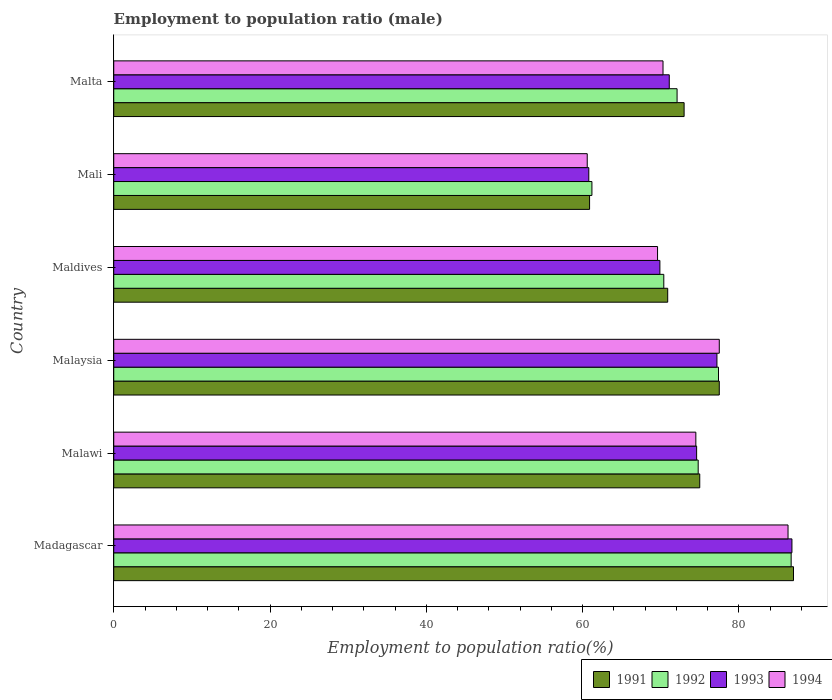How many groups of bars are there?
Make the answer very short. 6. Are the number of bars on each tick of the Y-axis equal?
Give a very brief answer. Yes. How many bars are there on the 5th tick from the top?
Your answer should be compact. 4. What is the label of the 3rd group of bars from the top?
Your answer should be compact. Maldives. In how many cases, is the number of bars for a given country not equal to the number of legend labels?
Keep it short and to the point. 0. What is the employment to population ratio in 1993 in Mali?
Ensure brevity in your answer.  60.8. Across all countries, what is the minimum employment to population ratio in 1992?
Offer a terse response. 61.2. In which country was the employment to population ratio in 1992 maximum?
Give a very brief answer. Madagascar. In which country was the employment to population ratio in 1993 minimum?
Offer a terse response. Mali. What is the total employment to population ratio in 1993 in the graph?
Provide a succinct answer. 440.4. What is the difference between the employment to population ratio in 1994 in Madagascar and that in Malawi?
Keep it short and to the point. 11.8. What is the difference between the employment to population ratio in 1993 in Maldives and the employment to population ratio in 1991 in Malawi?
Your answer should be compact. -5.1. What is the average employment to population ratio in 1992 per country?
Your response must be concise. 73.77. What is the difference between the employment to population ratio in 1994 and employment to population ratio in 1993 in Madagascar?
Your response must be concise. -0.5. What is the ratio of the employment to population ratio in 1992 in Malawi to that in Maldives?
Make the answer very short. 1.06. What is the difference between the highest and the second highest employment to population ratio in 1993?
Offer a terse response. 9.6. What is the difference between the highest and the lowest employment to population ratio in 1991?
Your answer should be compact. 26.1. Is the sum of the employment to population ratio in 1994 in Madagascar and Maldives greater than the maximum employment to population ratio in 1992 across all countries?
Your answer should be very brief. Yes. Is it the case that in every country, the sum of the employment to population ratio in 1992 and employment to population ratio in 1994 is greater than the sum of employment to population ratio in 1993 and employment to population ratio in 1991?
Provide a succinct answer. No. What does the 2nd bar from the top in Mali represents?
Make the answer very short. 1993. Is it the case that in every country, the sum of the employment to population ratio in 1991 and employment to population ratio in 1994 is greater than the employment to population ratio in 1992?
Your answer should be compact. Yes. What is the difference between two consecutive major ticks on the X-axis?
Your answer should be compact. 20. Does the graph contain any zero values?
Your answer should be very brief. No. Does the graph contain grids?
Make the answer very short. No. Where does the legend appear in the graph?
Make the answer very short. Bottom right. How many legend labels are there?
Ensure brevity in your answer.  4. How are the legend labels stacked?
Your answer should be very brief. Horizontal. What is the title of the graph?
Keep it short and to the point. Employment to population ratio (male). Does "2001" appear as one of the legend labels in the graph?
Offer a very short reply. No. What is the Employment to population ratio(%) of 1991 in Madagascar?
Ensure brevity in your answer.  87. What is the Employment to population ratio(%) in 1992 in Madagascar?
Offer a very short reply. 86.7. What is the Employment to population ratio(%) in 1993 in Madagascar?
Offer a terse response. 86.8. What is the Employment to population ratio(%) in 1994 in Madagascar?
Your answer should be very brief. 86.3. What is the Employment to population ratio(%) of 1991 in Malawi?
Your answer should be very brief. 75. What is the Employment to population ratio(%) in 1992 in Malawi?
Offer a very short reply. 74.8. What is the Employment to population ratio(%) in 1993 in Malawi?
Provide a short and direct response. 74.6. What is the Employment to population ratio(%) of 1994 in Malawi?
Keep it short and to the point. 74.5. What is the Employment to population ratio(%) in 1991 in Malaysia?
Provide a short and direct response. 77.5. What is the Employment to population ratio(%) in 1992 in Malaysia?
Provide a short and direct response. 77.4. What is the Employment to population ratio(%) of 1993 in Malaysia?
Your response must be concise. 77.2. What is the Employment to population ratio(%) of 1994 in Malaysia?
Offer a terse response. 77.5. What is the Employment to population ratio(%) of 1991 in Maldives?
Your answer should be compact. 70.9. What is the Employment to population ratio(%) in 1992 in Maldives?
Give a very brief answer. 70.4. What is the Employment to population ratio(%) of 1993 in Maldives?
Offer a terse response. 69.9. What is the Employment to population ratio(%) of 1994 in Maldives?
Your answer should be compact. 69.6. What is the Employment to population ratio(%) in 1991 in Mali?
Offer a very short reply. 60.9. What is the Employment to population ratio(%) in 1992 in Mali?
Your answer should be compact. 61.2. What is the Employment to population ratio(%) in 1993 in Mali?
Provide a succinct answer. 60.8. What is the Employment to population ratio(%) in 1994 in Mali?
Offer a terse response. 60.6. What is the Employment to population ratio(%) in 1992 in Malta?
Provide a short and direct response. 72.1. What is the Employment to population ratio(%) of 1993 in Malta?
Your answer should be very brief. 71.1. What is the Employment to population ratio(%) in 1994 in Malta?
Offer a terse response. 70.3. Across all countries, what is the maximum Employment to population ratio(%) of 1991?
Offer a very short reply. 87. Across all countries, what is the maximum Employment to population ratio(%) in 1992?
Make the answer very short. 86.7. Across all countries, what is the maximum Employment to population ratio(%) of 1993?
Provide a succinct answer. 86.8. Across all countries, what is the maximum Employment to population ratio(%) of 1994?
Give a very brief answer. 86.3. Across all countries, what is the minimum Employment to population ratio(%) of 1991?
Offer a terse response. 60.9. Across all countries, what is the minimum Employment to population ratio(%) in 1992?
Your answer should be compact. 61.2. Across all countries, what is the minimum Employment to population ratio(%) of 1993?
Keep it short and to the point. 60.8. Across all countries, what is the minimum Employment to population ratio(%) in 1994?
Your answer should be very brief. 60.6. What is the total Employment to population ratio(%) in 1991 in the graph?
Provide a short and direct response. 444.3. What is the total Employment to population ratio(%) of 1992 in the graph?
Make the answer very short. 442.6. What is the total Employment to population ratio(%) in 1993 in the graph?
Offer a very short reply. 440.4. What is the total Employment to population ratio(%) of 1994 in the graph?
Keep it short and to the point. 438.8. What is the difference between the Employment to population ratio(%) of 1993 in Madagascar and that in Malawi?
Ensure brevity in your answer.  12.2. What is the difference between the Employment to population ratio(%) in 1991 in Madagascar and that in Malaysia?
Make the answer very short. 9.5. What is the difference between the Employment to population ratio(%) in 1994 in Madagascar and that in Malaysia?
Ensure brevity in your answer.  8.8. What is the difference between the Employment to population ratio(%) in 1991 in Madagascar and that in Maldives?
Offer a terse response. 16.1. What is the difference between the Employment to population ratio(%) of 1992 in Madagascar and that in Maldives?
Offer a very short reply. 16.3. What is the difference between the Employment to population ratio(%) of 1991 in Madagascar and that in Mali?
Provide a short and direct response. 26.1. What is the difference between the Employment to population ratio(%) in 1993 in Madagascar and that in Mali?
Your answer should be compact. 26. What is the difference between the Employment to population ratio(%) of 1994 in Madagascar and that in Mali?
Ensure brevity in your answer.  25.7. What is the difference between the Employment to population ratio(%) in 1991 in Madagascar and that in Malta?
Your answer should be very brief. 14. What is the difference between the Employment to population ratio(%) of 1992 in Madagascar and that in Malta?
Keep it short and to the point. 14.6. What is the difference between the Employment to population ratio(%) of 1993 in Madagascar and that in Malta?
Provide a succinct answer. 15.7. What is the difference between the Employment to population ratio(%) of 1993 in Malawi and that in Malaysia?
Offer a very short reply. -2.6. What is the difference between the Employment to population ratio(%) in 1993 in Malawi and that in Maldives?
Offer a terse response. 4.7. What is the difference between the Employment to population ratio(%) in 1991 in Malawi and that in Mali?
Give a very brief answer. 14.1. What is the difference between the Employment to population ratio(%) in 1994 in Malawi and that in Mali?
Make the answer very short. 13.9. What is the difference between the Employment to population ratio(%) of 1991 in Malaysia and that in Maldives?
Give a very brief answer. 6.6. What is the difference between the Employment to population ratio(%) in 1992 in Malaysia and that in Maldives?
Offer a terse response. 7. What is the difference between the Employment to population ratio(%) of 1992 in Malaysia and that in Mali?
Offer a very short reply. 16.2. What is the difference between the Employment to population ratio(%) of 1993 in Malaysia and that in Mali?
Give a very brief answer. 16.4. What is the difference between the Employment to population ratio(%) in 1994 in Malaysia and that in Mali?
Give a very brief answer. 16.9. What is the difference between the Employment to population ratio(%) in 1994 in Malaysia and that in Malta?
Your answer should be compact. 7.2. What is the difference between the Employment to population ratio(%) of 1992 in Maldives and that in Mali?
Offer a terse response. 9.2. What is the difference between the Employment to population ratio(%) in 1994 in Maldives and that in Mali?
Give a very brief answer. 9. What is the difference between the Employment to population ratio(%) of 1991 in Maldives and that in Malta?
Offer a terse response. -2.1. What is the difference between the Employment to population ratio(%) in 1994 in Maldives and that in Malta?
Give a very brief answer. -0.7. What is the difference between the Employment to population ratio(%) in 1991 in Mali and that in Malta?
Give a very brief answer. -12.1. What is the difference between the Employment to population ratio(%) of 1993 in Mali and that in Malta?
Provide a succinct answer. -10.3. What is the difference between the Employment to population ratio(%) of 1991 in Madagascar and the Employment to population ratio(%) of 1992 in Malawi?
Your response must be concise. 12.2. What is the difference between the Employment to population ratio(%) in 1992 in Madagascar and the Employment to population ratio(%) in 1994 in Malawi?
Your answer should be very brief. 12.2. What is the difference between the Employment to population ratio(%) in 1993 in Madagascar and the Employment to population ratio(%) in 1994 in Malawi?
Ensure brevity in your answer.  12.3. What is the difference between the Employment to population ratio(%) in 1991 in Madagascar and the Employment to population ratio(%) in 1992 in Malaysia?
Your answer should be very brief. 9.6. What is the difference between the Employment to population ratio(%) of 1992 in Madagascar and the Employment to population ratio(%) of 1993 in Malaysia?
Offer a terse response. 9.5. What is the difference between the Employment to population ratio(%) in 1992 in Madagascar and the Employment to population ratio(%) in 1994 in Malaysia?
Ensure brevity in your answer.  9.2. What is the difference between the Employment to population ratio(%) in 1993 in Madagascar and the Employment to population ratio(%) in 1994 in Malaysia?
Provide a short and direct response. 9.3. What is the difference between the Employment to population ratio(%) of 1991 in Madagascar and the Employment to population ratio(%) of 1992 in Maldives?
Provide a short and direct response. 16.6. What is the difference between the Employment to population ratio(%) of 1991 in Madagascar and the Employment to population ratio(%) of 1993 in Maldives?
Provide a short and direct response. 17.1. What is the difference between the Employment to population ratio(%) in 1992 in Madagascar and the Employment to population ratio(%) in 1994 in Maldives?
Keep it short and to the point. 17.1. What is the difference between the Employment to population ratio(%) in 1993 in Madagascar and the Employment to population ratio(%) in 1994 in Maldives?
Make the answer very short. 17.2. What is the difference between the Employment to population ratio(%) of 1991 in Madagascar and the Employment to population ratio(%) of 1992 in Mali?
Offer a terse response. 25.8. What is the difference between the Employment to population ratio(%) in 1991 in Madagascar and the Employment to population ratio(%) in 1993 in Mali?
Make the answer very short. 26.2. What is the difference between the Employment to population ratio(%) of 1991 in Madagascar and the Employment to population ratio(%) of 1994 in Mali?
Your response must be concise. 26.4. What is the difference between the Employment to population ratio(%) in 1992 in Madagascar and the Employment to population ratio(%) in 1993 in Mali?
Give a very brief answer. 25.9. What is the difference between the Employment to population ratio(%) in 1992 in Madagascar and the Employment to population ratio(%) in 1994 in Mali?
Your answer should be compact. 26.1. What is the difference between the Employment to population ratio(%) in 1993 in Madagascar and the Employment to population ratio(%) in 1994 in Mali?
Your answer should be compact. 26.2. What is the difference between the Employment to population ratio(%) in 1991 in Madagascar and the Employment to population ratio(%) in 1993 in Malta?
Keep it short and to the point. 15.9. What is the difference between the Employment to population ratio(%) of 1992 in Madagascar and the Employment to population ratio(%) of 1993 in Malta?
Your response must be concise. 15.6. What is the difference between the Employment to population ratio(%) in 1992 in Madagascar and the Employment to population ratio(%) in 1994 in Malta?
Your answer should be compact. 16.4. What is the difference between the Employment to population ratio(%) in 1991 in Malawi and the Employment to population ratio(%) in 1992 in Malaysia?
Ensure brevity in your answer.  -2.4. What is the difference between the Employment to population ratio(%) in 1992 in Malawi and the Employment to population ratio(%) in 1994 in Malaysia?
Provide a short and direct response. -2.7. What is the difference between the Employment to population ratio(%) in 1991 in Malawi and the Employment to population ratio(%) in 1992 in Maldives?
Provide a short and direct response. 4.6. What is the difference between the Employment to population ratio(%) of 1991 in Malawi and the Employment to population ratio(%) of 1993 in Maldives?
Your response must be concise. 5.1. What is the difference between the Employment to population ratio(%) in 1991 in Malawi and the Employment to population ratio(%) in 1992 in Mali?
Give a very brief answer. 13.8. What is the difference between the Employment to population ratio(%) of 1993 in Malawi and the Employment to population ratio(%) of 1994 in Mali?
Give a very brief answer. 14. What is the difference between the Employment to population ratio(%) in 1991 in Malawi and the Employment to population ratio(%) in 1992 in Malta?
Offer a terse response. 2.9. What is the difference between the Employment to population ratio(%) of 1991 in Malaysia and the Employment to population ratio(%) of 1994 in Maldives?
Give a very brief answer. 7.9. What is the difference between the Employment to population ratio(%) of 1992 in Malaysia and the Employment to population ratio(%) of 1993 in Maldives?
Your answer should be compact. 7.5. What is the difference between the Employment to population ratio(%) of 1993 in Malaysia and the Employment to population ratio(%) of 1994 in Maldives?
Give a very brief answer. 7.6. What is the difference between the Employment to population ratio(%) of 1991 in Malaysia and the Employment to population ratio(%) of 1992 in Mali?
Provide a succinct answer. 16.3. What is the difference between the Employment to population ratio(%) in 1991 in Malaysia and the Employment to population ratio(%) in 1993 in Mali?
Offer a very short reply. 16.7. What is the difference between the Employment to population ratio(%) of 1991 in Malaysia and the Employment to population ratio(%) of 1994 in Mali?
Your answer should be very brief. 16.9. What is the difference between the Employment to population ratio(%) of 1992 in Malaysia and the Employment to population ratio(%) of 1994 in Mali?
Your answer should be compact. 16.8. What is the difference between the Employment to population ratio(%) of 1993 in Malaysia and the Employment to population ratio(%) of 1994 in Mali?
Ensure brevity in your answer.  16.6. What is the difference between the Employment to population ratio(%) of 1991 in Malaysia and the Employment to population ratio(%) of 1992 in Malta?
Give a very brief answer. 5.4. What is the difference between the Employment to population ratio(%) of 1991 in Malaysia and the Employment to population ratio(%) of 1994 in Malta?
Keep it short and to the point. 7.2. What is the difference between the Employment to population ratio(%) of 1992 in Malaysia and the Employment to population ratio(%) of 1993 in Malta?
Provide a succinct answer. 6.3. What is the difference between the Employment to population ratio(%) of 1991 in Maldives and the Employment to population ratio(%) of 1993 in Mali?
Your answer should be compact. 10.1. What is the difference between the Employment to population ratio(%) of 1992 in Maldives and the Employment to population ratio(%) of 1994 in Mali?
Give a very brief answer. 9.8. What is the difference between the Employment to population ratio(%) in 1991 in Maldives and the Employment to population ratio(%) in 1993 in Malta?
Provide a succinct answer. -0.2. What is the difference between the Employment to population ratio(%) in 1993 in Maldives and the Employment to population ratio(%) in 1994 in Malta?
Make the answer very short. -0.4. What is the difference between the Employment to population ratio(%) in 1991 in Mali and the Employment to population ratio(%) in 1993 in Malta?
Ensure brevity in your answer.  -10.2. What is the difference between the Employment to population ratio(%) in 1991 in Mali and the Employment to population ratio(%) in 1994 in Malta?
Your answer should be very brief. -9.4. What is the difference between the Employment to population ratio(%) in 1992 in Mali and the Employment to population ratio(%) in 1993 in Malta?
Make the answer very short. -9.9. What is the difference between the Employment to population ratio(%) in 1992 in Mali and the Employment to population ratio(%) in 1994 in Malta?
Offer a very short reply. -9.1. What is the average Employment to population ratio(%) of 1991 per country?
Ensure brevity in your answer.  74.05. What is the average Employment to population ratio(%) in 1992 per country?
Offer a very short reply. 73.77. What is the average Employment to population ratio(%) of 1993 per country?
Your answer should be compact. 73.4. What is the average Employment to population ratio(%) in 1994 per country?
Provide a succinct answer. 73.13. What is the difference between the Employment to population ratio(%) of 1992 and Employment to population ratio(%) of 1993 in Madagascar?
Ensure brevity in your answer.  -0.1. What is the difference between the Employment to population ratio(%) in 1992 and Employment to population ratio(%) in 1994 in Madagascar?
Provide a short and direct response. 0.4. What is the difference between the Employment to population ratio(%) in 1991 and Employment to population ratio(%) in 1993 in Malawi?
Offer a very short reply. 0.4. What is the difference between the Employment to population ratio(%) in 1991 and Employment to population ratio(%) in 1994 in Malawi?
Provide a short and direct response. 0.5. What is the difference between the Employment to population ratio(%) of 1991 and Employment to population ratio(%) of 1992 in Malaysia?
Your response must be concise. 0.1. What is the difference between the Employment to population ratio(%) in 1991 and Employment to population ratio(%) in 1993 in Malaysia?
Ensure brevity in your answer.  0.3. What is the difference between the Employment to population ratio(%) in 1991 and Employment to population ratio(%) in 1994 in Malaysia?
Offer a terse response. 0. What is the difference between the Employment to population ratio(%) of 1992 and Employment to population ratio(%) of 1994 in Malaysia?
Provide a succinct answer. -0.1. What is the difference between the Employment to population ratio(%) of 1993 and Employment to population ratio(%) of 1994 in Malaysia?
Give a very brief answer. -0.3. What is the difference between the Employment to population ratio(%) in 1991 and Employment to population ratio(%) in 1992 in Maldives?
Your answer should be very brief. 0.5. What is the difference between the Employment to population ratio(%) of 1993 and Employment to population ratio(%) of 1994 in Maldives?
Offer a terse response. 0.3. What is the difference between the Employment to population ratio(%) in 1991 and Employment to population ratio(%) in 1992 in Mali?
Provide a short and direct response. -0.3. What is the difference between the Employment to population ratio(%) of 1991 and Employment to population ratio(%) of 1993 in Mali?
Your response must be concise. 0.1. What is the difference between the Employment to population ratio(%) in 1991 and Employment to population ratio(%) in 1994 in Mali?
Offer a very short reply. 0.3. What is the difference between the Employment to population ratio(%) of 1992 and Employment to population ratio(%) of 1993 in Mali?
Your answer should be very brief. 0.4. What is the difference between the Employment to population ratio(%) in 1993 and Employment to population ratio(%) in 1994 in Mali?
Your answer should be compact. 0.2. What is the difference between the Employment to population ratio(%) in 1991 and Employment to population ratio(%) in 1992 in Malta?
Offer a terse response. 0.9. What is the difference between the Employment to population ratio(%) in 1991 and Employment to population ratio(%) in 1994 in Malta?
Your answer should be compact. 2.7. What is the difference between the Employment to population ratio(%) of 1992 and Employment to population ratio(%) of 1993 in Malta?
Keep it short and to the point. 1. What is the ratio of the Employment to population ratio(%) in 1991 in Madagascar to that in Malawi?
Your answer should be very brief. 1.16. What is the ratio of the Employment to population ratio(%) in 1992 in Madagascar to that in Malawi?
Your answer should be very brief. 1.16. What is the ratio of the Employment to population ratio(%) of 1993 in Madagascar to that in Malawi?
Provide a short and direct response. 1.16. What is the ratio of the Employment to population ratio(%) of 1994 in Madagascar to that in Malawi?
Make the answer very short. 1.16. What is the ratio of the Employment to population ratio(%) in 1991 in Madagascar to that in Malaysia?
Make the answer very short. 1.12. What is the ratio of the Employment to population ratio(%) of 1992 in Madagascar to that in Malaysia?
Your answer should be compact. 1.12. What is the ratio of the Employment to population ratio(%) in 1993 in Madagascar to that in Malaysia?
Offer a very short reply. 1.12. What is the ratio of the Employment to population ratio(%) of 1994 in Madagascar to that in Malaysia?
Provide a succinct answer. 1.11. What is the ratio of the Employment to population ratio(%) in 1991 in Madagascar to that in Maldives?
Offer a terse response. 1.23. What is the ratio of the Employment to population ratio(%) of 1992 in Madagascar to that in Maldives?
Give a very brief answer. 1.23. What is the ratio of the Employment to population ratio(%) of 1993 in Madagascar to that in Maldives?
Offer a very short reply. 1.24. What is the ratio of the Employment to population ratio(%) in 1994 in Madagascar to that in Maldives?
Your answer should be very brief. 1.24. What is the ratio of the Employment to population ratio(%) in 1991 in Madagascar to that in Mali?
Your answer should be compact. 1.43. What is the ratio of the Employment to population ratio(%) in 1992 in Madagascar to that in Mali?
Your response must be concise. 1.42. What is the ratio of the Employment to population ratio(%) of 1993 in Madagascar to that in Mali?
Offer a very short reply. 1.43. What is the ratio of the Employment to population ratio(%) in 1994 in Madagascar to that in Mali?
Your answer should be compact. 1.42. What is the ratio of the Employment to population ratio(%) of 1991 in Madagascar to that in Malta?
Your answer should be compact. 1.19. What is the ratio of the Employment to population ratio(%) of 1992 in Madagascar to that in Malta?
Provide a short and direct response. 1.2. What is the ratio of the Employment to population ratio(%) in 1993 in Madagascar to that in Malta?
Offer a very short reply. 1.22. What is the ratio of the Employment to population ratio(%) in 1994 in Madagascar to that in Malta?
Your response must be concise. 1.23. What is the ratio of the Employment to population ratio(%) in 1991 in Malawi to that in Malaysia?
Keep it short and to the point. 0.97. What is the ratio of the Employment to population ratio(%) of 1992 in Malawi to that in Malaysia?
Make the answer very short. 0.97. What is the ratio of the Employment to population ratio(%) in 1993 in Malawi to that in Malaysia?
Your answer should be very brief. 0.97. What is the ratio of the Employment to population ratio(%) of 1994 in Malawi to that in Malaysia?
Offer a very short reply. 0.96. What is the ratio of the Employment to population ratio(%) of 1991 in Malawi to that in Maldives?
Give a very brief answer. 1.06. What is the ratio of the Employment to population ratio(%) in 1993 in Malawi to that in Maldives?
Offer a very short reply. 1.07. What is the ratio of the Employment to population ratio(%) in 1994 in Malawi to that in Maldives?
Provide a succinct answer. 1.07. What is the ratio of the Employment to population ratio(%) of 1991 in Malawi to that in Mali?
Your answer should be very brief. 1.23. What is the ratio of the Employment to population ratio(%) of 1992 in Malawi to that in Mali?
Offer a very short reply. 1.22. What is the ratio of the Employment to population ratio(%) of 1993 in Malawi to that in Mali?
Provide a succinct answer. 1.23. What is the ratio of the Employment to population ratio(%) in 1994 in Malawi to that in Mali?
Your answer should be very brief. 1.23. What is the ratio of the Employment to population ratio(%) in 1991 in Malawi to that in Malta?
Give a very brief answer. 1.03. What is the ratio of the Employment to population ratio(%) in 1992 in Malawi to that in Malta?
Provide a succinct answer. 1.04. What is the ratio of the Employment to population ratio(%) of 1993 in Malawi to that in Malta?
Provide a succinct answer. 1.05. What is the ratio of the Employment to population ratio(%) in 1994 in Malawi to that in Malta?
Your response must be concise. 1.06. What is the ratio of the Employment to population ratio(%) in 1991 in Malaysia to that in Maldives?
Your answer should be very brief. 1.09. What is the ratio of the Employment to population ratio(%) in 1992 in Malaysia to that in Maldives?
Ensure brevity in your answer.  1.1. What is the ratio of the Employment to population ratio(%) of 1993 in Malaysia to that in Maldives?
Your response must be concise. 1.1. What is the ratio of the Employment to population ratio(%) of 1994 in Malaysia to that in Maldives?
Your answer should be compact. 1.11. What is the ratio of the Employment to population ratio(%) in 1991 in Malaysia to that in Mali?
Provide a succinct answer. 1.27. What is the ratio of the Employment to population ratio(%) in 1992 in Malaysia to that in Mali?
Offer a terse response. 1.26. What is the ratio of the Employment to population ratio(%) in 1993 in Malaysia to that in Mali?
Keep it short and to the point. 1.27. What is the ratio of the Employment to population ratio(%) in 1994 in Malaysia to that in Mali?
Your response must be concise. 1.28. What is the ratio of the Employment to population ratio(%) in 1991 in Malaysia to that in Malta?
Give a very brief answer. 1.06. What is the ratio of the Employment to population ratio(%) of 1992 in Malaysia to that in Malta?
Your answer should be compact. 1.07. What is the ratio of the Employment to population ratio(%) in 1993 in Malaysia to that in Malta?
Provide a short and direct response. 1.09. What is the ratio of the Employment to population ratio(%) in 1994 in Malaysia to that in Malta?
Keep it short and to the point. 1.1. What is the ratio of the Employment to population ratio(%) of 1991 in Maldives to that in Mali?
Give a very brief answer. 1.16. What is the ratio of the Employment to population ratio(%) of 1992 in Maldives to that in Mali?
Provide a short and direct response. 1.15. What is the ratio of the Employment to population ratio(%) in 1993 in Maldives to that in Mali?
Provide a short and direct response. 1.15. What is the ratio of the Employment to population ratio(%) in 1994 in Maldives to that in Mali?
Ensure brevity in your answer.  1.15. What is the ratio of the Employment to population ratio(%) in 1991 in Maldives to that in Malta?
Offer a very short reply. 0.97. What is the ratio of the Employment to population ratio(%) of 1992 in Maldives to that in Malta?
Ensure brevity in your answer.  0.98. What is the ratio of the Employment to population ratio(%) in 1993 in Maldives to that in Malta?
Your answer should be very brief. 0.98. What is the ratio of the Employment to population ratio(%) of 1994 in Maldives to that in Malta?
Your answer should be compact. 0.99. What is the ratio of the Employment to population ratio(%) of 1991 in Mali to that in Malta?
Provide a short and direct response. 0.83. What is the ratio of the Employment to population ratio(%) in 1992 in Mali to that in Malta?
Give a very brief answer. 0.85. What is the ratio of the Employment to population ratio(%) in 1993 in Mali to that in Malta?
Offer a very short reply. 0.86. What is the ratio of the Employment to population ratio(%) in 1994 in Mali to that in Malta?
Make the answer very short. 0.86. What is the difference between the highest and the second highest Employment to population ratio(%) in 1991?
Your answer should be very brief. 9.5. What is the difference between the highest and the second highest Employment to population ratio(%) in 1992?
Your answer should be compact. 9.3. What is the difference between the highest and the second highest Employment to population ratio(%) of 1993?
Offer a very short reply. 9.6. What is the difference between the highest and the lowest Employment to population ratio(%) of 1991?
Keep it short and to the point. 26.1. What is the difference between the highest and the lowest Employment to population ratio(%) of 1994?
Give a very brief answer. 25.7. 